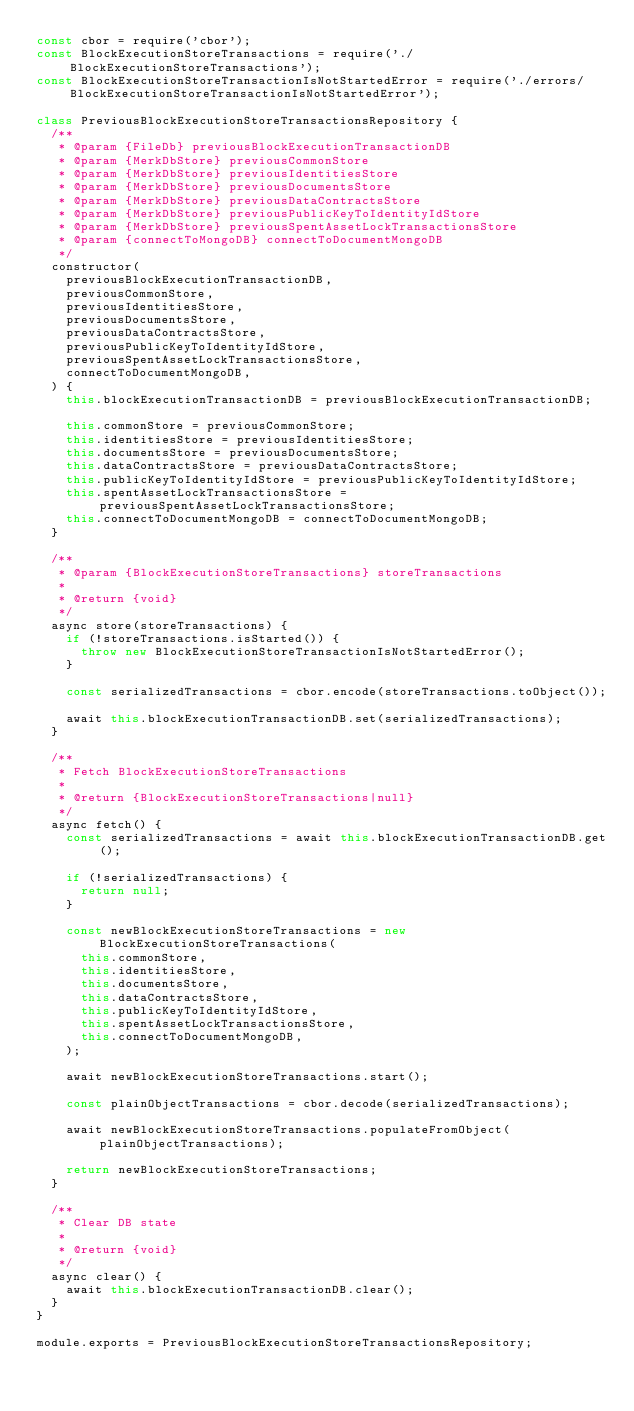<code> <loc_0><loc_0><loc_500><loc_500><_JavaScript_>const cbor = require('cbor');
const BlockExecutionStoreTransactions = require('./BlockExecutionStoreTransactions');
const BlockExecutionStoreTransactionIsNotStartedError = require('./errors/BlockExecutionStoreTransactionIsNotStartedError');

class PreviousBlockExecutionStoreTransactionsRepository {
  /**
   * @param {FileDb} previousBlockExecutionTransactionDB
   * @param {MerkDbStore} previousCommonStore
   * @param {MerkDbStore} previousIdentitiesStore
   * @param {MerkDbStore} previousDocumentsStore
   * @param {MerkDbStore} previousDataContractsStore
   * @param {MerkDbStore} previousPublicKeyToIdentityIdStore
   * @param {MerkDbStore} previousSpentAssetLockTransactionsStore
   * @param {connectToMongoDB} connectToDocumentMongoDB
   */
  constructor(
    previousBlockExecutionTransactionDB,
    previousCommonStore,
    previousIdentitiesStore,
    previousDocumentsStore,
    previousDataContractsStore,
    previousPublicKeyToIdentityIdStore,
    previousSpentAssetLockTransactionsStore,
    connectToDocumentMongoDB,
  ) {
    this.blockExecutionTransactionDB = previousBlockExecutionTransactionDB;

    this.commonStore = previousCommonStore;
    this.identitiesStore = previousIdentitiesStore;
    this.documentsStore = previousDocumentsStore;
    this.dataContractsStore = previousDataContractsStore;
    this.publicKeyToIdentityIdStore = previousPublicKeyToIdentityIdStore;
    this.spentAssetLockTransactionsStore = previousSpentAssetLockTransactionsStore;
    this.connectToDocumentMongoDB = connectToDocumentMongoDB;
  }

  /**
   * @param {BlockExecutionStoreTransactions} storeTransactions
   *
   * @return {void}
   */
  async store(storeTransactions) {
    if (!storeTransactions.isStarted()) {
      throw new BlockExecutionStoreTransactionIsNotStartedError();
    }

    const serializedTransactions = cbor.encode(storeTransactions.toObject());

    await this.blockExecutionTransactionDB.set(serializedTransactions);
  }

  /**
   * Fetch BlockExecutionStoreTransactions
   *
   * @return {BlockExecutionStoreTransactions|null}
   */
  async fetch() {
    const serializedTransactions = await this.blockExecutionTransactionDB.get();

    if (!serializedTransactions) {
      return null;
    }

    const newBlockExecutionStoreTransactions = new BlockExecutionStoreTransactions(
      this.commonStore,
      this.identitiesStore,
      this.documentsStore,
      this.dataContractsStore,
      this.publicKeyToIdentityIdStore,
      this.spentAssetLockTransactionsStore,
      this.connectToDocumentMongoDB,
    );

    await newBlockExecutionStoreTransactions.start();

    const plainObjectTransactions = cbor.decode(serializedTransactions);

    await newBlockExecutionStoreTransactions.populateFromObject(plainObjectTransactions);

    return newBlockExecutionStoreTransactions;
  }

  /**
   * Clear DB state
   *
   * @return {void}
   */
  async clear() {
    await this.blockExecutionTransactionDB.clear();
  }
}

module.exports = PreviousBlockExecutionStoreTransactionsRepository;
</code> 